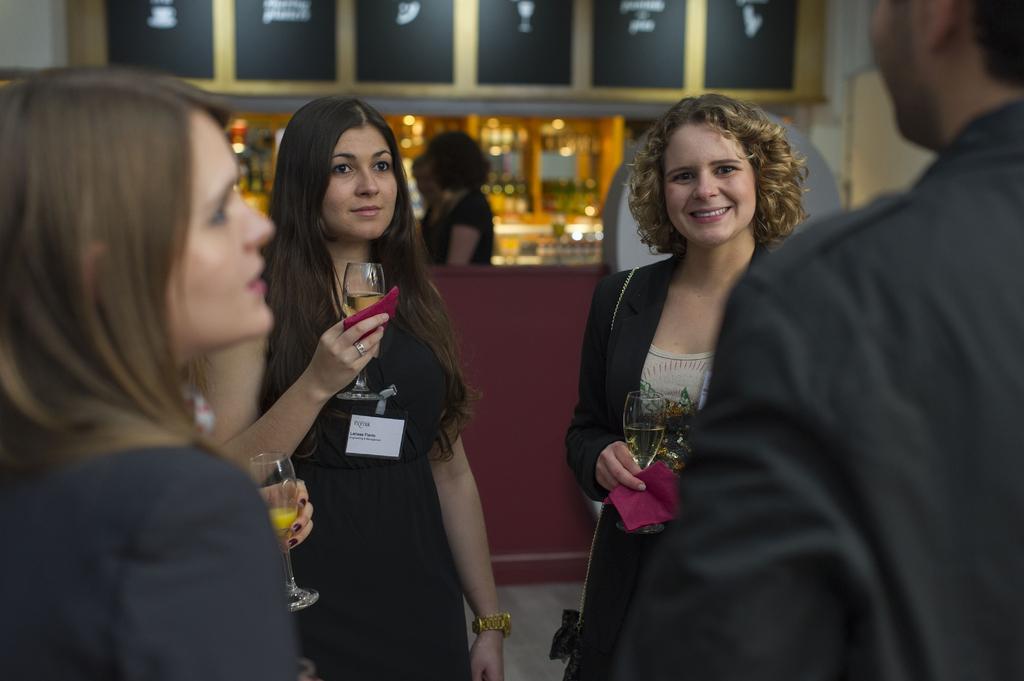Please provide a concise description of this image. In this picture there is a woman who is wearing black dress and holding a wine glass. Beside her there is another woman who is also holding a wine glass. On the left there is a woman who is wearing blazer. On the right there is a man who is wearing a black color shirt. In the back I can see two persons who are standing near to the table. Beside him I can see the white bottles and glasses. 